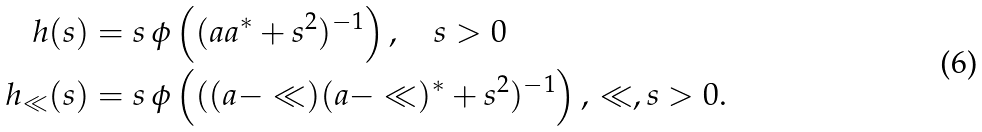Convert formula to latex. <formula><loc_0><loc_0><loc_500><loc_500>h ( s ) & = s \, \phi \left ( ( a a ^ { \ast } + s ^ { 2 } ) ^ { - 1 } \right ) , \quad s > 0 \\ h _ { \ll } ( s ) & = s \, \phi \left ( ( ( a - \ll ) ( a - \ll ) ^ { \ast } + s ^ { 2 } ) ^ { - 1 } \right ) , \, \ll , s > 0 .</formula> 